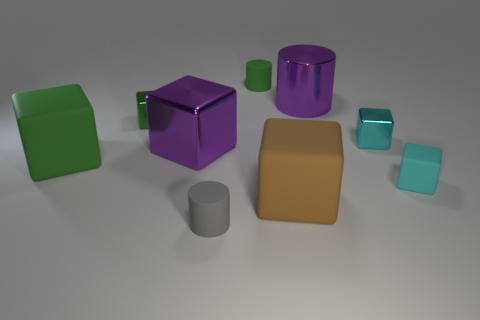Subtract 3 cubes. How many cubes are left? 3 Subtract all green cubes. How many cubes are left? 4 Subtract all green blocks. How many blocks are left? 4 Subtract all yellow blocks. Subtract all green spheres. How many blocks are left? 6 Add 1 small cyan metal objects. How many objects exist? 10 Subtract all blocks. How many objects are left? 3 Subtract all gray matte things. Subtract all gray cylinders. How many objects are left? 7 Add 9 small green rubber cylinders. How many small green rubber cylinders are left? 10 Add 2 big cylinders. How many big cylinders exist? 3 Subtract 0 blue blocks. How many objects are left? 9 